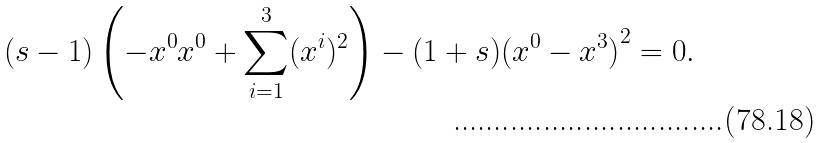Convert formula to latex. <formula><loc_0><loc_0><loc_500><loc_500>( s - 1 ) \left ( - x ^ { 0 } x ^ { 0 } + \sum _ { i = 1 } ^ { 3 } ( x ^ { i } ) ^ { 2 } \right ) - ( 1 + s ) { ( x ^ { 0 } - x ^ { 3 } ) } ^ { 2 } & = 0 .</formula> 